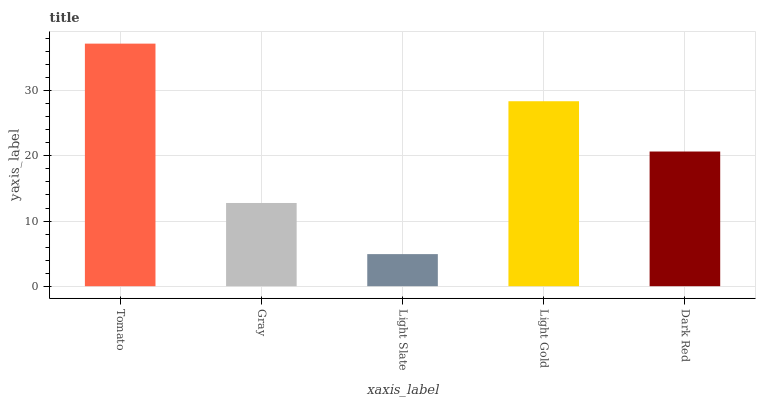Is Light Slate the minimum?
Answer yes or no. Yes. Is Tomato the maximum?
Answer yes or no. Yes. Is Gray the minimum?
Answer yes or no. No. Is Gray the maximum?
Answer yes or no. No. Is Tomato greater than Gray?
Answer yes or no. Yes. Is Gray less than Tomato?
Answer yes or no. Yes. Is Gray greater than Tomato?
Answer yes or no. No. Is Tomato less than Gray?
Answer yes or no. No. Is Dark Red the high median?
Answer yes or no. Yes. Is Dark Red the low median?
Answer yes or no. Yes. Is Gray the high median?
Answer yes or no. No. Is Light Gold the low median?
Answer yes or no. No. 